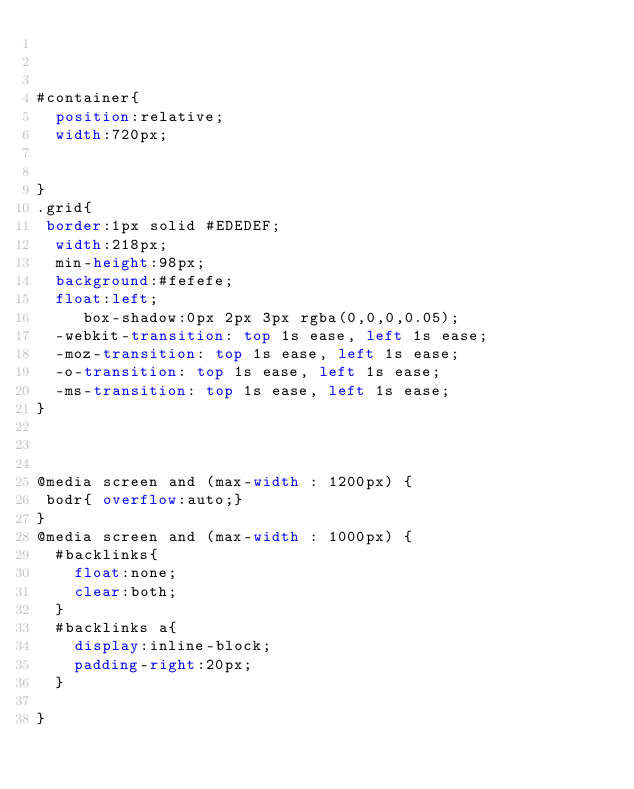Convert code to text. <code><loc_0><loc_0><loc_500><loc_500><_CSS_>


#container{
	position:relative;
	width:720px; 

	
}
.grid{
 border:1px solid #EDEDEF;
	width:218px;
	min-height:98px;
	background:#fefefe;
	float:left;
     box-shadow:0px 2px 3px rgba(0,0,0,0.05);
	-webkit-transition: top 1s ease, left 1s ease;
	-moz-transition: top 1s ease, left 1s ease;
	-o-transition: top 1s ease, left 1s ease;
	-ms-transition: top 1s ease, left 1s ease;
}



@media screen and (max-width : 1200px) {
 bodr{ overflow:auto;}
}
@media screen and (max-width : 1000px) {
	#backlinks{
		float:none;
		clear:both;
	}
	#backlinks a{
		display:inline-block;
		padding-right:20px;
	}

}</code> 